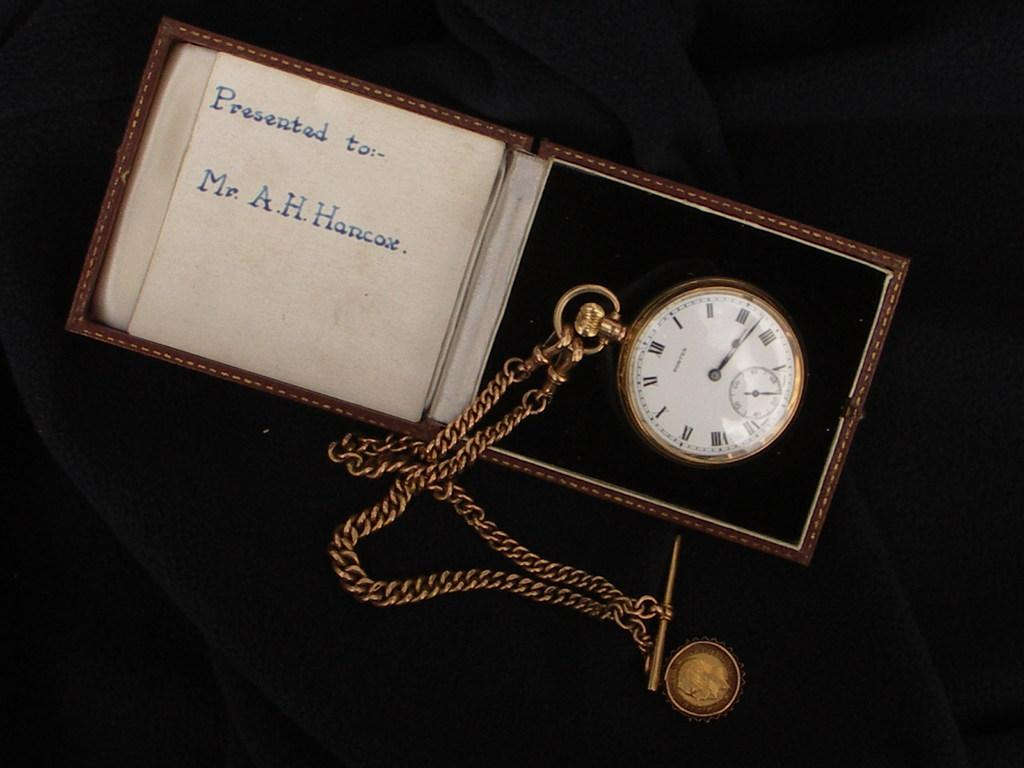<image>
Provide a brief description of the given image. A pocket watch is in a box with Presented to:- Mr. A.H. Hancox written inside of the box. 